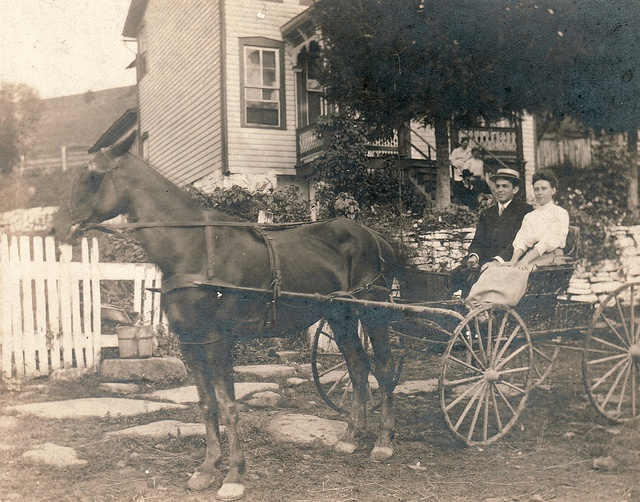Describe the objects in this image and their specific colors. I can see horse in ivory, gray, and purple tones, people in ivory, beige, tan, and darkgray tones, people in beige, gray, black, and purple tones, people in ivory, black, gray, darkblue, and darkgray tones, and people in ivory, darkgray, tan, gray, and black tones in this image. 